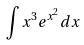Convert formula to latex. <formula><loc_0><loc_0><loc_500><loc_500>\int x ^ { 3 } e ^ { x ^ { 2 } } d x</formula> 